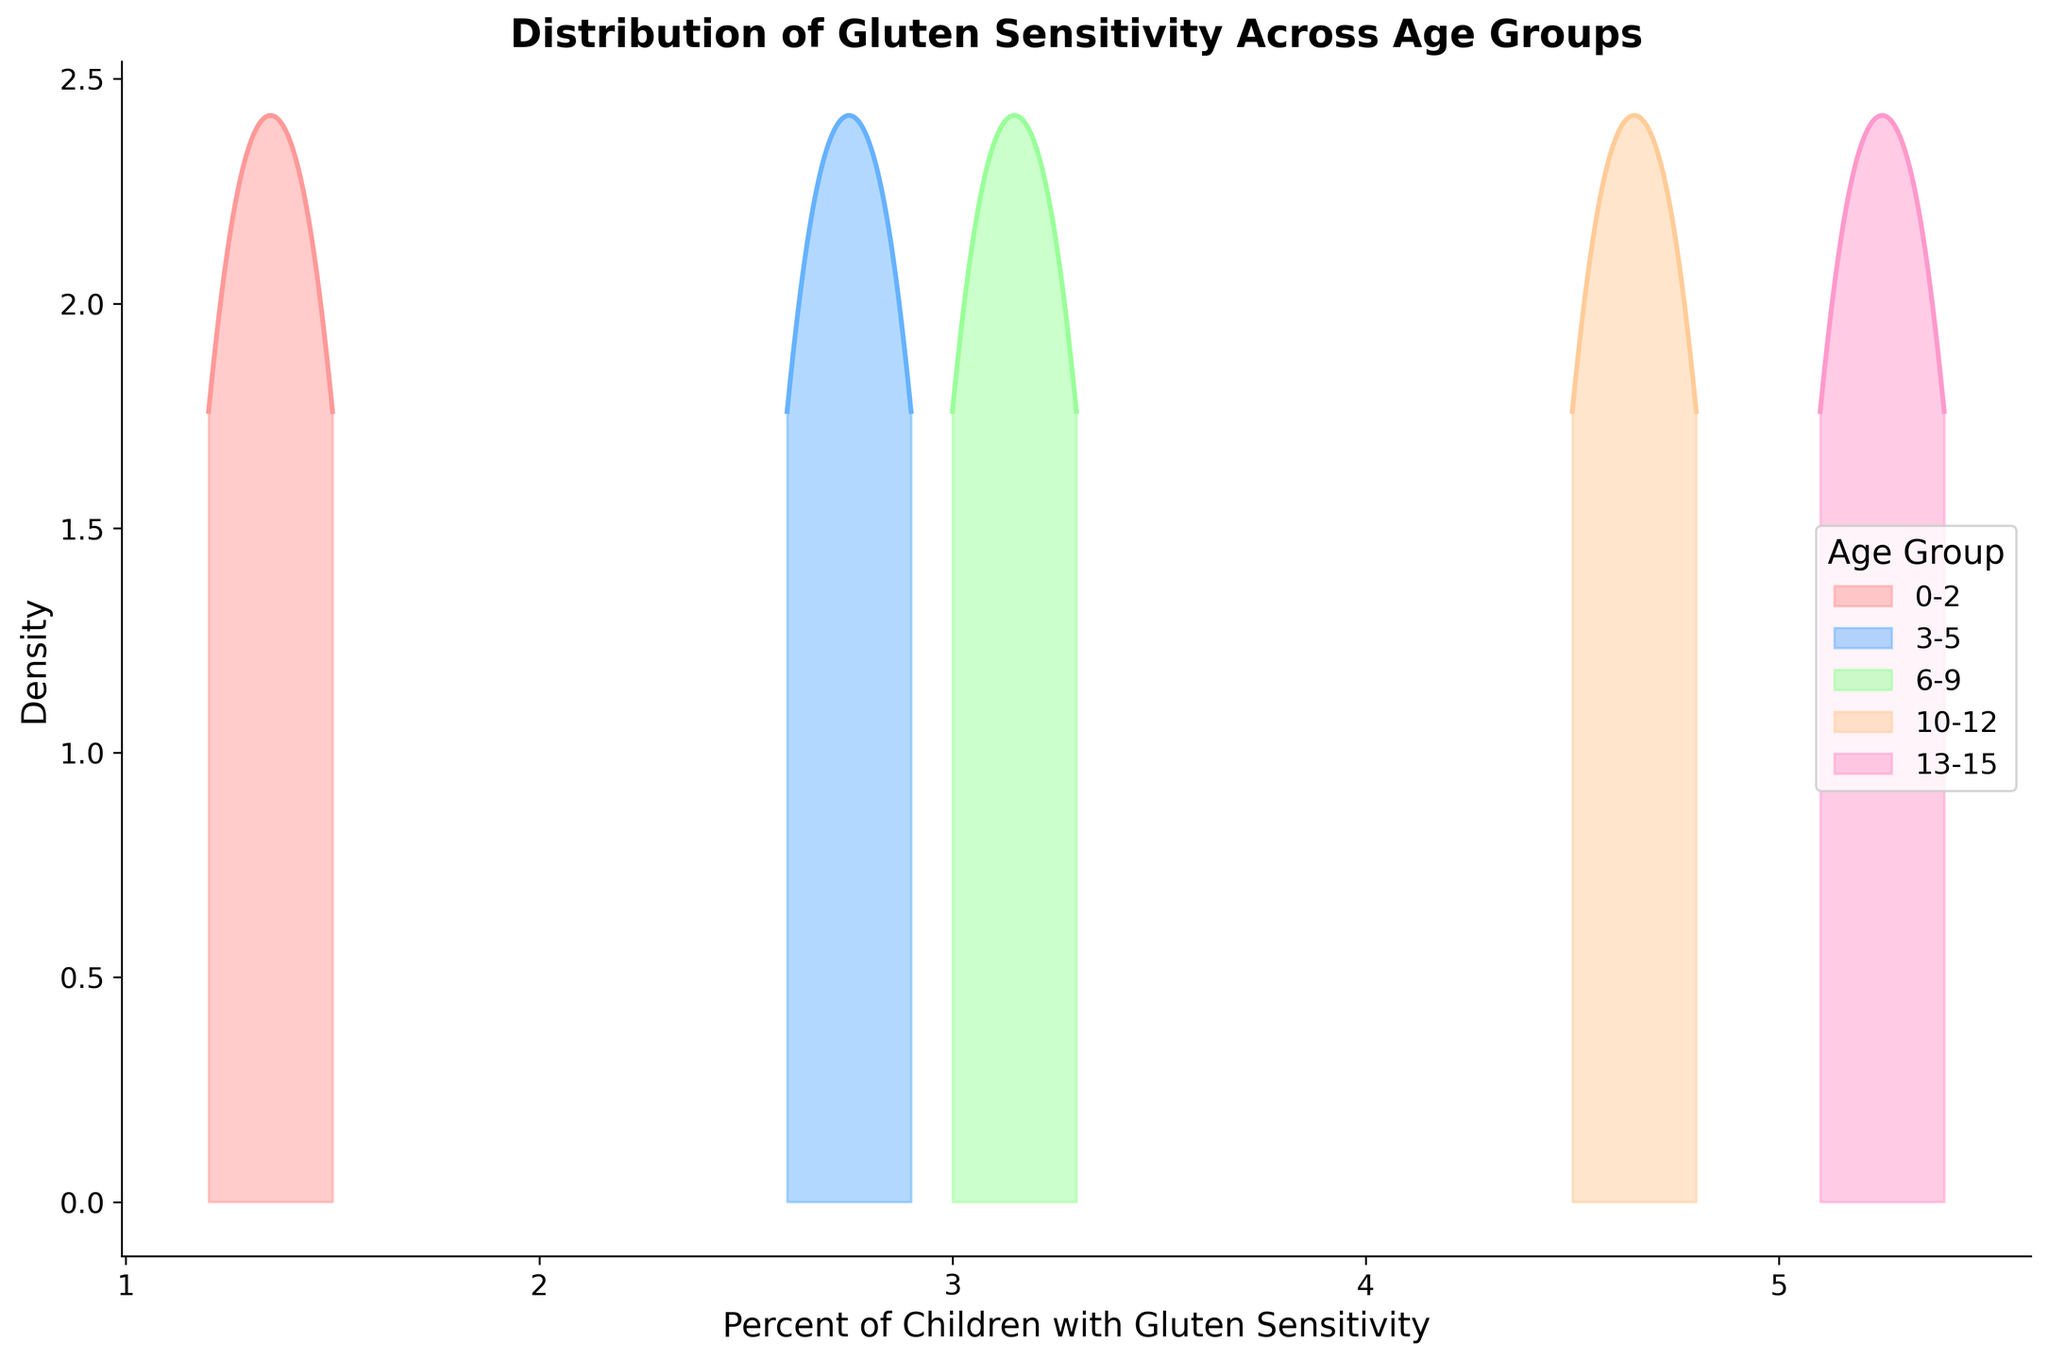What's the title of the figure? The title of any figure is usually found at the top and is there to provide an overview of the key topic presented.
Answer: Distribution of Gluten Sensitivity Across Age Groups What is represented on the x-axis? The x-axis in the figure typically represents the primary data variable being analyzed. Here, it indicates the "Percent of Children with Gluten Sensitivity."
Answer: Percent of Children with Gluten Sensitivity Which age group shows the highest density peak? The highest density peak indicates the age group where the concentration of data points within a range is highest. By looking at the peaks for different age groups, we can identify which one has the tallest peak.
Answer: 13-15 How does the density of gluten sensitivity change as children age from 0-2 to 13-15? Examining the density peaks for each age group shows the trend in gluten sensitivity levels as children age. Younger groups, starting from 0-2, have density peaks at lower percentages. As the age group increases to 13-15, the density peaks shift to higher values, indicating an increase in gluten sensitivity prevalence.
Answer: Increases Which age group has more variability in the percentage of gluten sensitivity, 0-2 or 10-12? Variability can be assessed by looking at the spread of the density plot. A wider spread means higher variability. By comparing the width of the density curves for age groups 0-2 and 10-12, we can determine which has a broader range. Age group 10-12 has a wider spread compared to 0-2.
Answer: 10-12 What is the range of the percentage of children with gluten sensitivity for the age group 3-5? The range of a distribution can be observed by identifying the minimum and maximum values within the density curve for a specific age group. Here, we examine the curve for 3-5 years old children. The range spans from approximately 2.6% to 2.9%.
Answer: 2.6% to 2.9% Between the age groups 6-9 and 10-12, which one has a higher median percentage of gluten sensitivity? The median value is located at the center of the density curve. By finding the mid-point or peak of each density curve, we compare the age group 6-9 and 10-12. The peak for 10-12 is higher than that of 6-9.
Answer: 10-12 Which age group shows the steepest increase in density? The steepest increase in density can be observed by identifying which curve has a sharp rise from its baseline to its peak. The density plot for the age group 13-15 shows the steepest increase.
Answer: 13-15 How does the density plot for the age group 0-2 compare to that for the age group 13-15 in terms of shape? Comparing the shapes of the density plots helps in understanding the distribution characteristics. The 0-2 age group has a more gradual increase and a flatter peak, while the 13-15 age group has a sharper increase and a taller, narrower peak.
Answer: Flatter and gradual for 0-2, sharper and taller for 13-15 